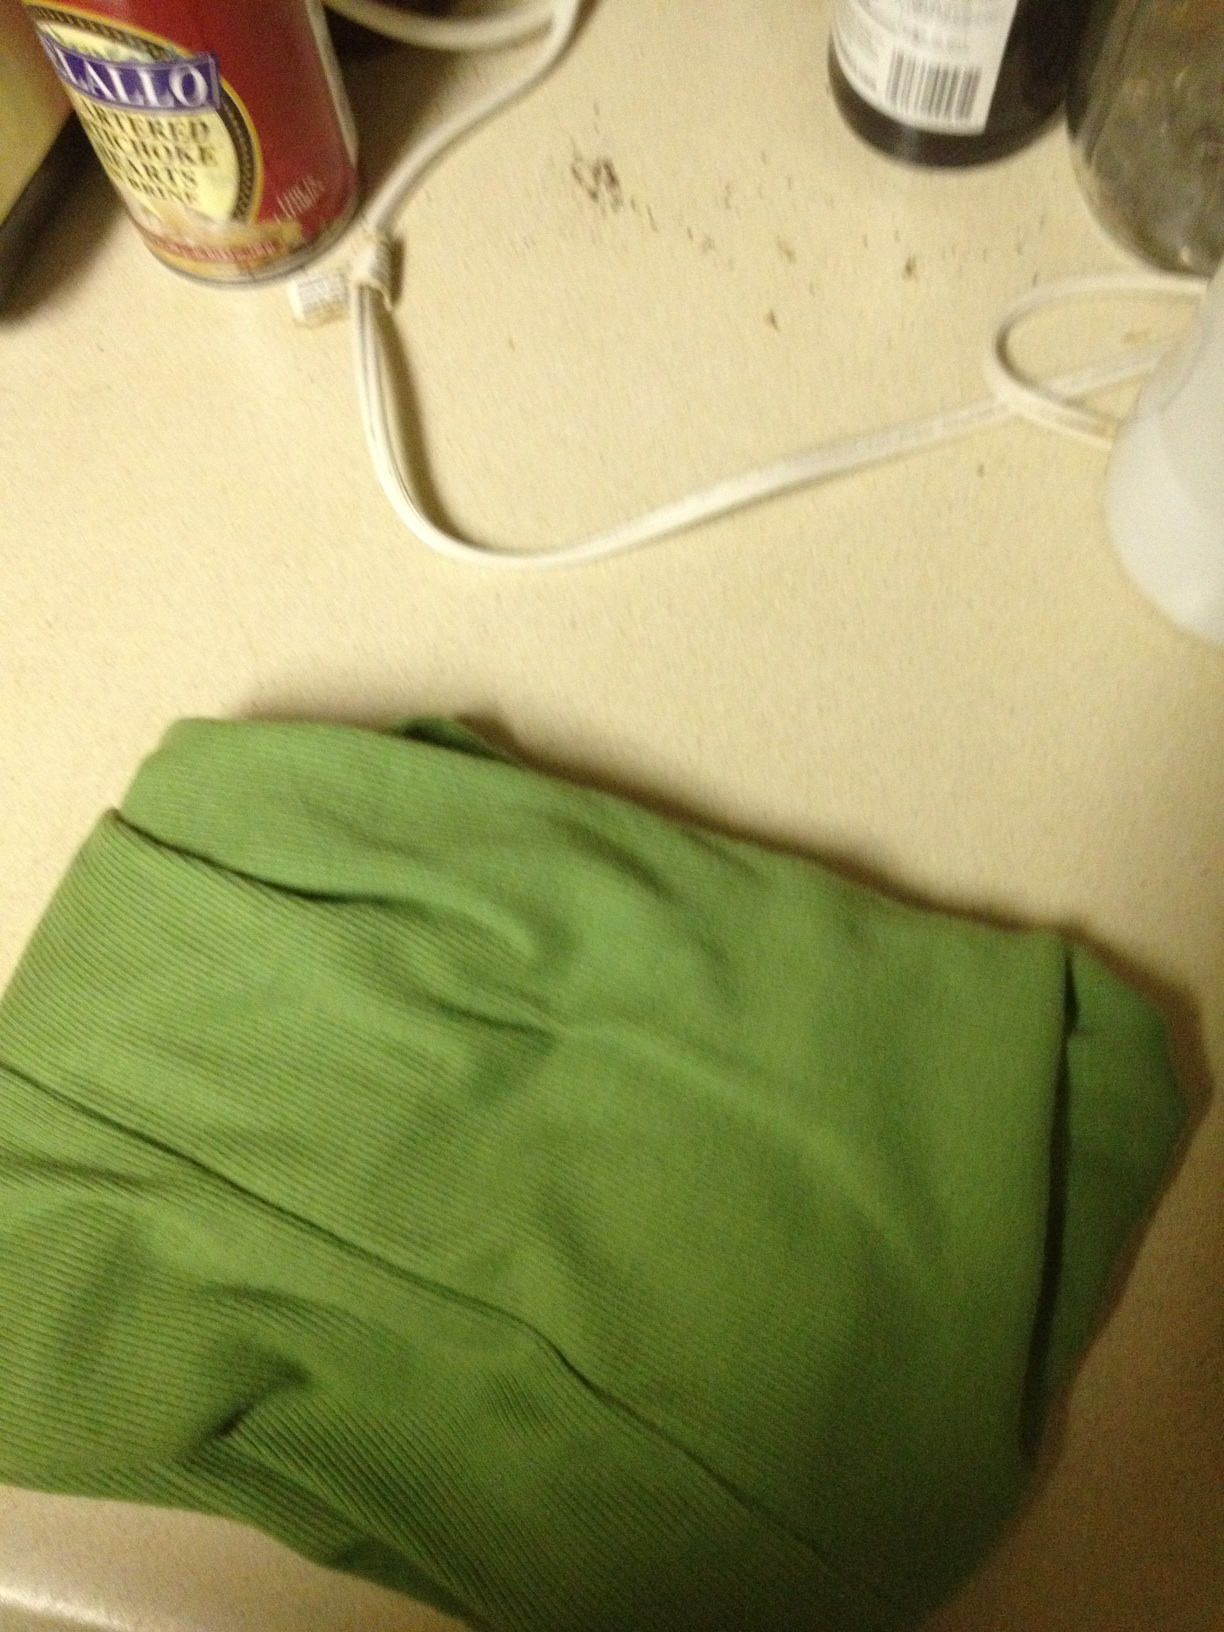What items are surrounding the shirt in the image? Surrounding the shirt, there appear to be some household items, including a can of food, a bottle, and an electrical cord. This setting suggests it might be a kitchen or a utility area. Do you think the shirt is clean or dirty? The shirt looks neatly folded, which suggests it is clean. However, cleanliness cannot be determined solely by appearance in an image without inspecting it closely. 